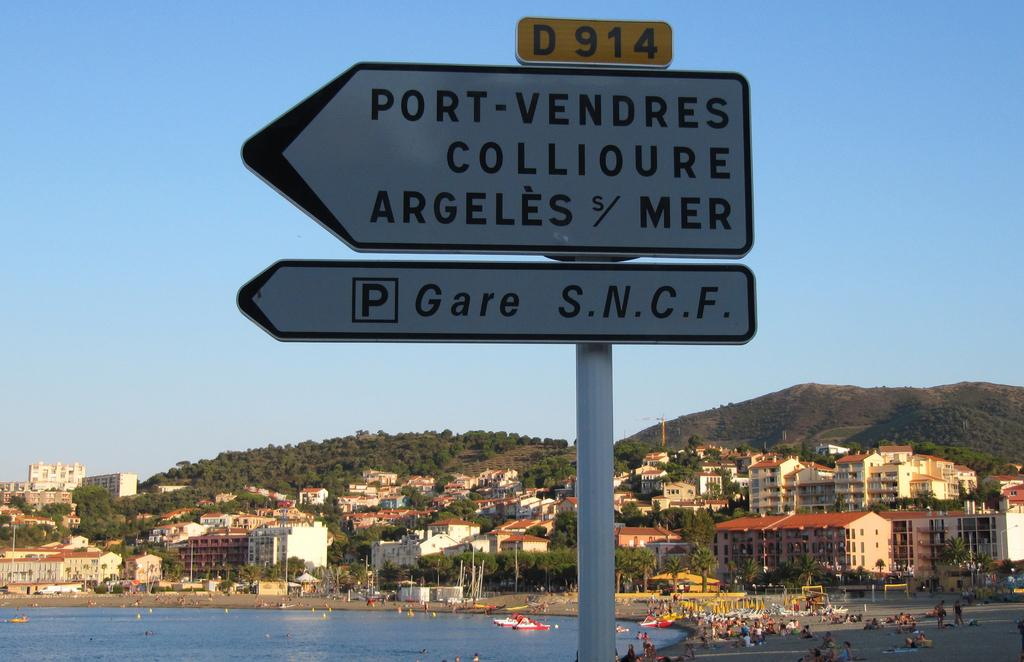<image>
Describe the image concisely. a sign that has the word port on it 